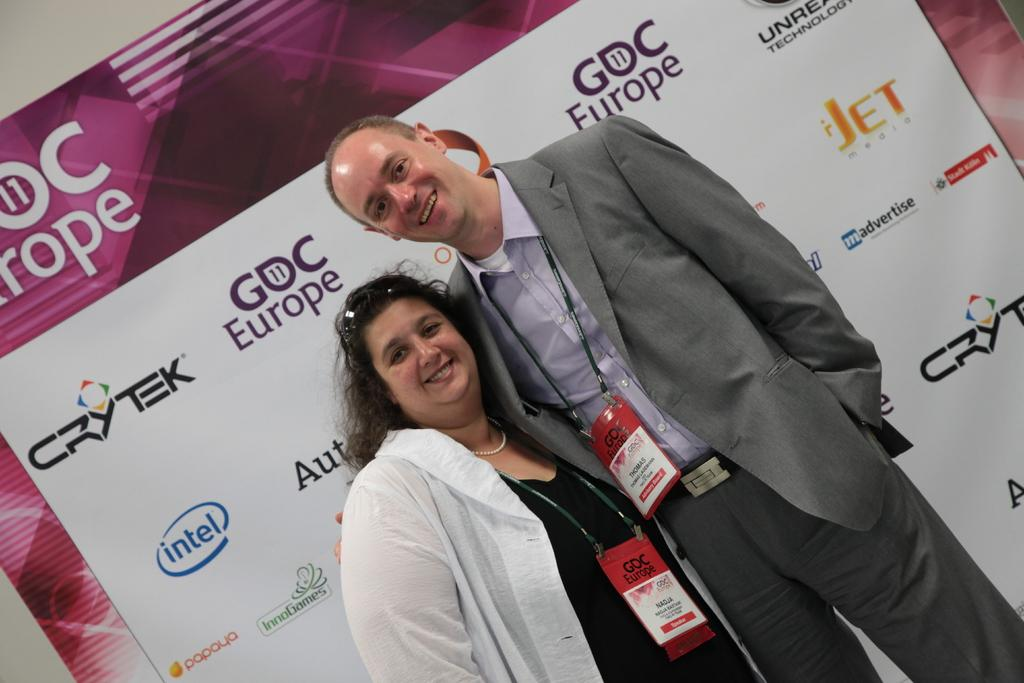Who are the people in the image? There is a man and a lady in the image. What are they wearing that is visible in the image? Both the man and the lady are wearing ID cards. What can be seen in the background of the image? There is a board in the background of the image. What is written or displayed on the board? There is text visible on the board, and there are also logos visible. What type of sonic apparatus is being used by the man in the image? There is no sonic apparatus visible in the image; the man and the lady are wearing ID cards and standing near a board with text and logos. What is the acoustics of the room like in the image? The image does not provide any information about the acoustics of the room. 